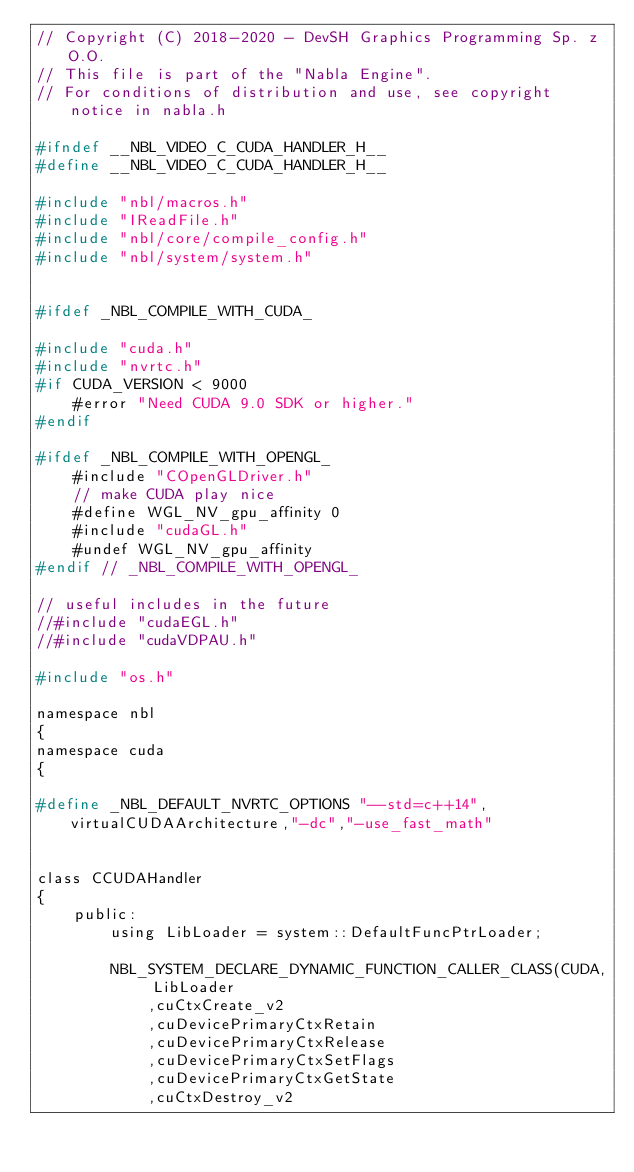<code> <loc_0><loc_0><loc_500><loc_500><_C_>// Copyright (C) 2018-2020 - DevSH Graphics Programming Sp. z O.O.
// This file is part of the "Nabla Engine".
// For conditions of distribution and use, see copyright notice in nabla.h

#ifndef __NBL_VIDEO_C_CUDA_HANDLER_H__
#define __NBL_VIDEO_C_CUDA_HANDLER_H__

#include "nbl/macros.h"
#include "IReadFile.h"
#include "nbl/core/compile_config.h"
#include "nbl/system/system.h"


#ifdef _NBL_COMPILE_WITH_CUDA_

#include "cuda.h"
#include "nvrtc.h"
#if CUDA_VERSION < 9000
	#error "Need CUDA 9.0 SDK or higher."
#endif

#ifdef _NBL_COMPILE_WITH_OPENGL_
	#include "COpenGLDriver.h"
	// make CUDA play nice
	#define WGL_NV_gpu_affinity 0
	#include "cudaGL.h"
	#undef WGL_NV_gpu_affinity
#endif // _NBL_COMPILE_WITH_OPENGL_

// useful includes in the future
//#include "cudaEGL.h"
//#include "cudaVDPAU.h"

#include "os.h"

namespace nbl
{
namespace cuda
{

#define _NBL_DEFAULT_NVRTC_OPTIONS "--std=c++14",virtualCUDAArchitecture,"-dc","-use_fast_math"


class CCUDAHandler
{
    public:
		using LibLoader = system::DefaultFuncPtrLoader;

		NBL_SYSTEM_DECLARE_DYNAMIC_FUNCTION_CALLER_CLASS(CUDA, LibLoader
			,cuCtxCreate_v2
			,cuDevicePrimaryCtxRetain
			,cuDevicePrimaryCtxRelease
			,cuDevicePrimaryCtxSetFlags
			,cuDevicePrimaryCtxGetState
			,cuCtxDestroy_v2</code> 